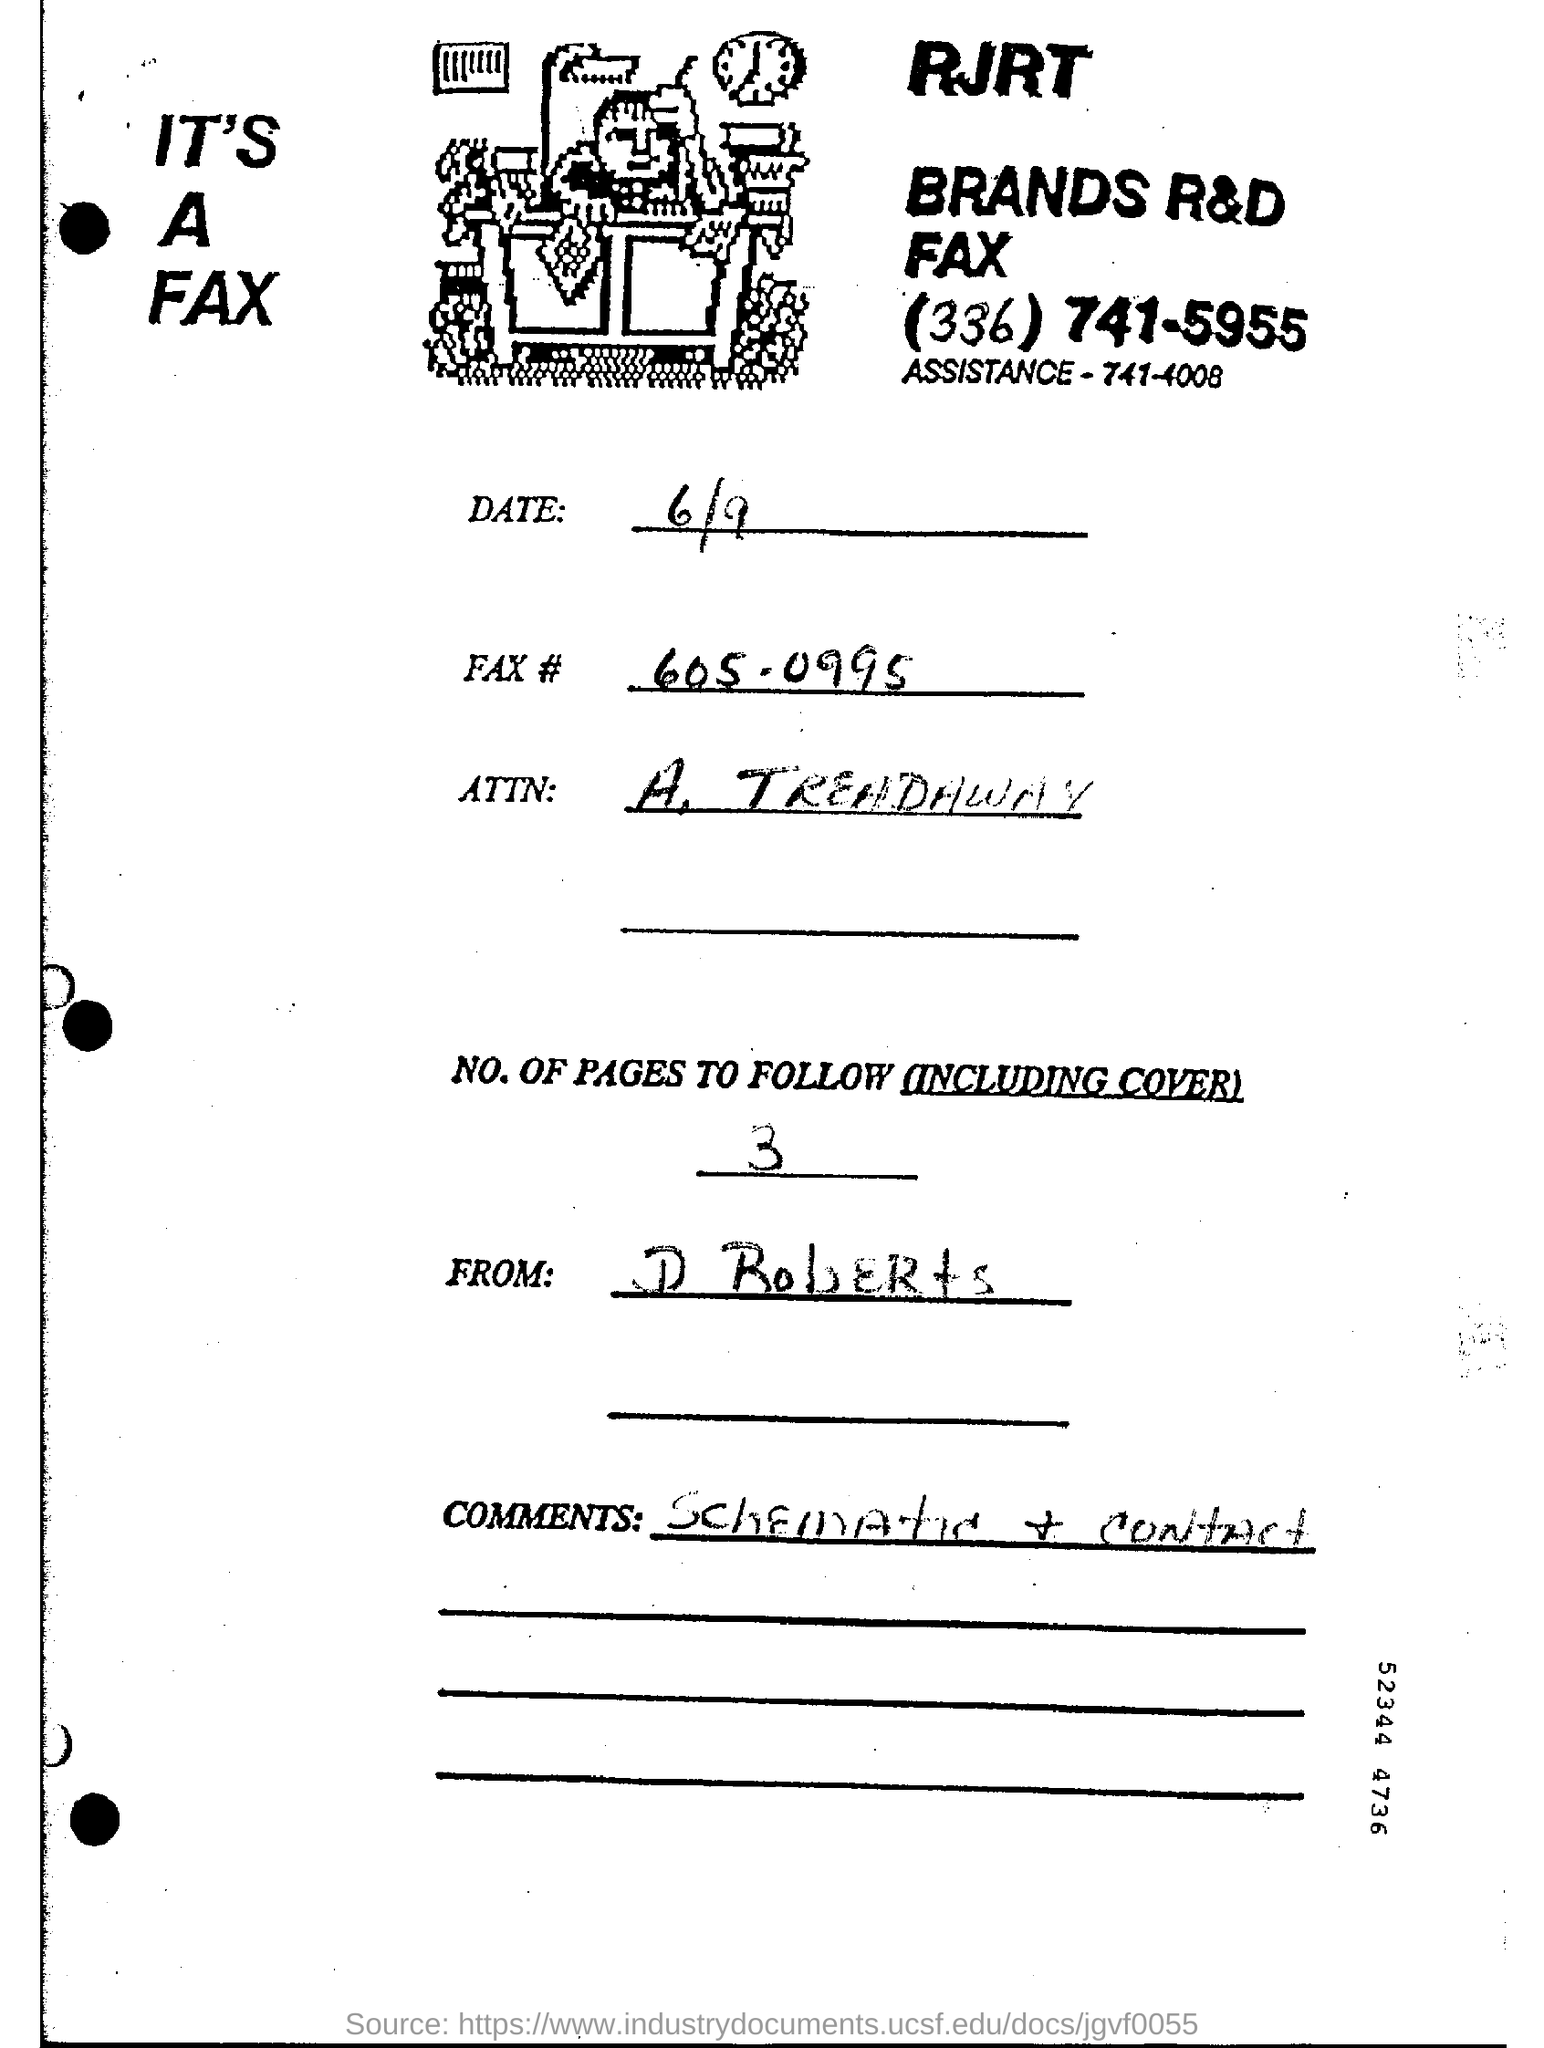Highlight a few significant elements in this photo. The date being asked is June 9th. Comments, schematic, and contact information are provided. The number of pages to follow, including the cover, is three. 